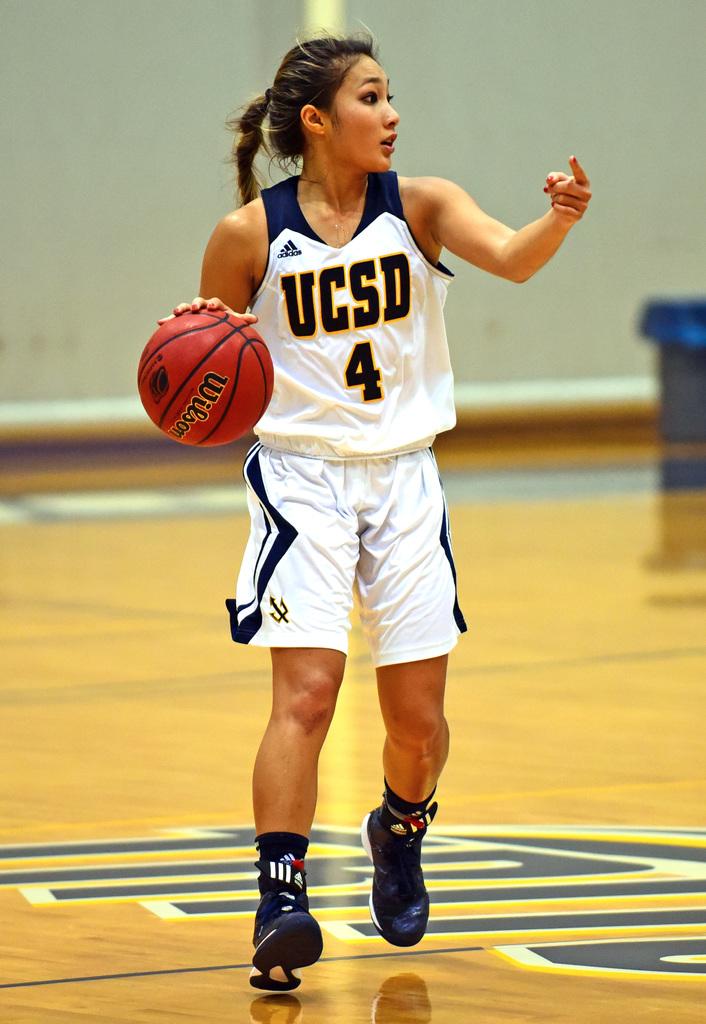What kind of basketball is this player using?
Your response must be concise. Wilson. What is her team?
Provide a short and direct response. Ucsd. 